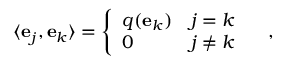Convert formula to latex. <formula><loc_0><loc_0><loc_500><loc_500>\langle e _ { j } , e _ { k } \rangle = \left \{ { \begin{array} { l l } { q ( e _ { k } ) } & { j = k } \\ { 0 } & { j \neq k } \end{array} } \quad ,</formula> 